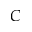Convert formula to latex. <formula><loc_0><loc_0><loc_500><loc_500>C</formula> 